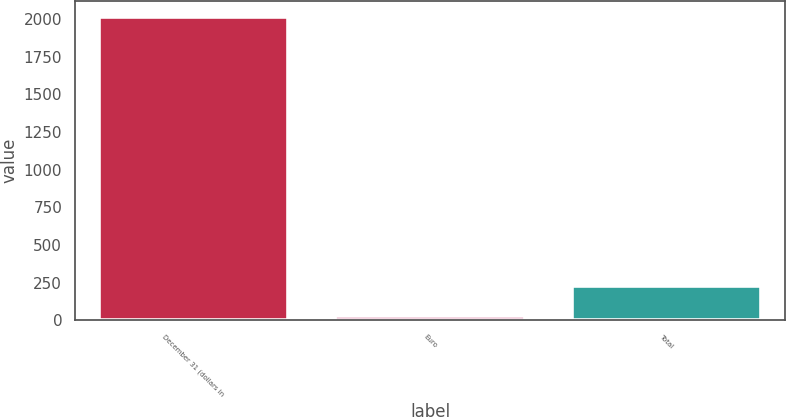<chart> <loc_0><loc_0><loc_500><loc_500><bar_chart><fcel>December 31 (dollars in<fcel>Euro<fcel>Total<nl><fcel>2016<fcel>25.4<fcel>224.46<nl></chart> 